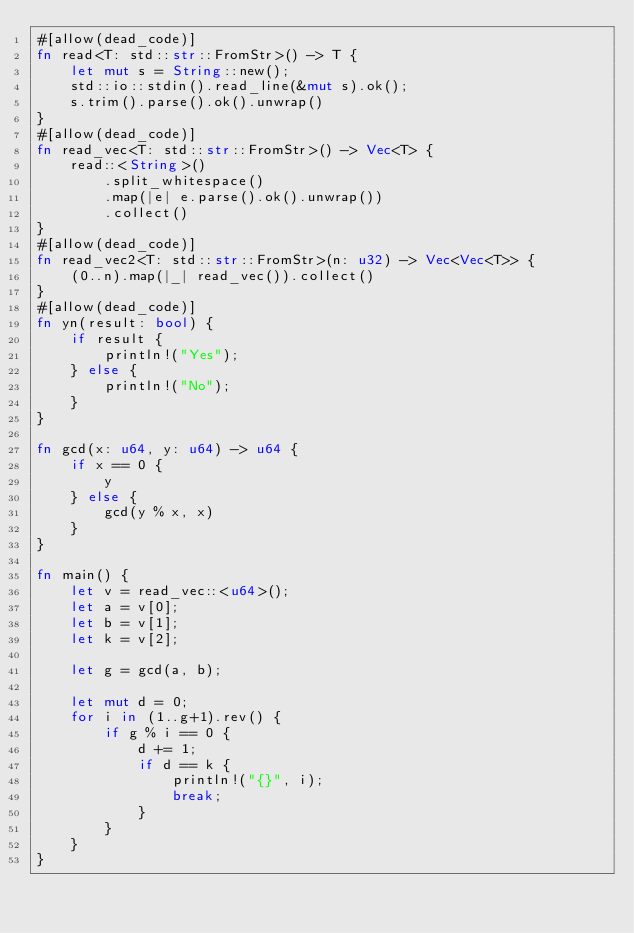<code> <loc_0><loc_0><loc_500><loc_500><_Rust_>#[allow(dead_code)]
fn read<T: std::str::FromStr>() -> T {
    let mut s = String::new();
    std::io::stdin().read_line(&mut s).ok();
    s.trim().parse().ok().unwrap()
}
#[allow(dead_code)]
fn read_vec<T: std::str::FromStr>() -> Vec<T> {
    read::<String>()
        .split_whitespace()
        .map(|e| e.parse().ok().unwrap())
        .collect()
}
#[allow(dead_code)]
fn read_vec2<T: std::str::FromStr>(n: u32) -> Vec<Vec<T>> {
    (0..n).map(|_| read_vec()).collect()
}
#[allow(dead_code)]
fn yn(result: bool) {
    if result {
        println!("Yes");
    } else {
        println!("No");
    }
}

fn gcd(x: u64, y: u64) -> u64 {
    if x == 0 {
        y
    } else {
        gcd(y % x, x)
    }
}

fn main() {
    let v = read_vec::<u64>();
    let a = v[0];
    let b = v[1];
    let k = v[2];

    let g = gcd(a, b);

    let mut d = 0;
    for i in (1..g+1).rev() {
        if g % i == 0 {
            d += 1;
            if d == k {
                println!("{}", i);
                break;
            }
        }
    }
}
</code> 